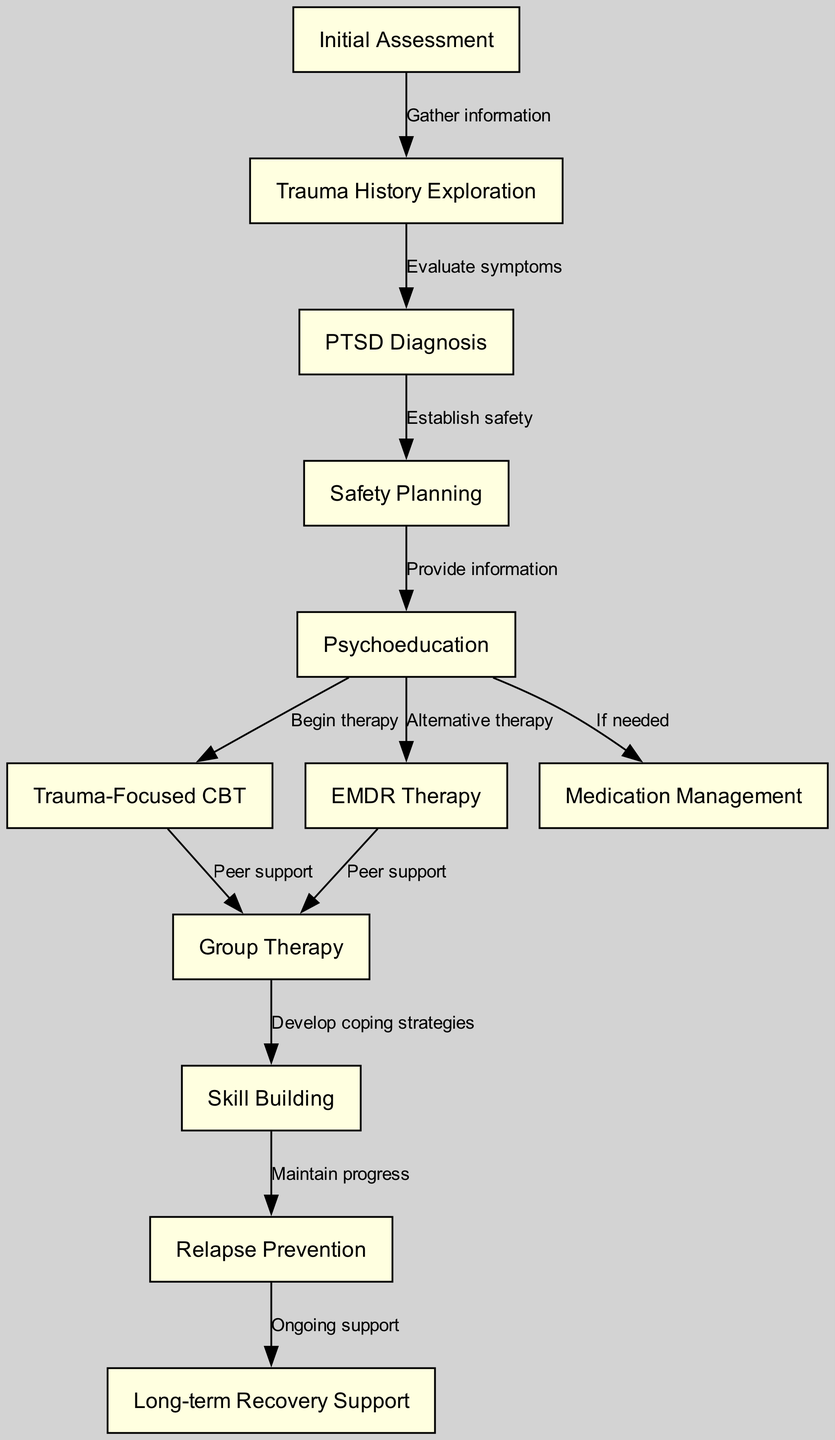What is the first step in the treatment pathway? The first step is "Initial Assessment," which is denoted as node 1 in the diagram.
Answer: Initial Assessment How many therapy options are provided in the pathway? There are three therapy options listed: "Trauma-Focused CBT," "EMDR Therapy," and "Group Therapy," which correspond to nodes 6, 7, and 8 respectively.
Answer: 3 What follows after the "PTSD Diagnosis"? After "PTSD Diagnosis," the next step is "Safety Planning," which is shown as node 4 linked directly to node 3.
Answer: Safety Planning Which node provides information about treatment methods? The node that provides psychoeducation is "Psychoeducation," which is node 5 and links to multiple therapy options including trauma-focused therapy and medications.
Answer: Psychoeducation What is the last step in the treatment pathway? The last step is "Long-term Recovery Support," which is represented by node 12 at the end of the diagram flow.
Answer: Long-term Recovery Support What are the two alternative therapies mentioned in the pathway? The two alternative therapies mentioned are "EMDR Therapy" and "Group Therapy," as indicated in nodes 7 and 8.
Answer: EMDR Therapy, Group Therapy What connects "Group Therapy" to "Skill Building"? "Group Therapy" connects to "Skill Building" through the edge indicating the development of coping strategies following participation in group sessions.
Answer: Develop coping strategies How many edges are in the diagram? The total number of edges in the diagram is 11, representing the connections between various steps in the treatment pathway.
Answer: 11 